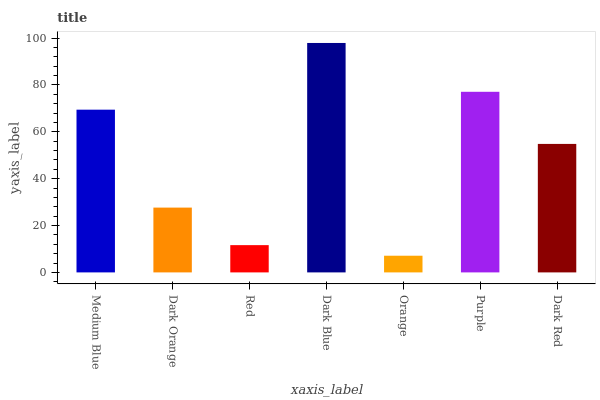Is Orange the minimum?
Answer yes or no. Yes. Is Dark Blue the maximum?
Answer yes or no. Yes. Is Dark Orange the minimum?
Answer yes or no. No. Is Dark Orange the maximum?
Answer yes or no. No. Is Medium Blue greater than Dark Orange?
Answer yes or no. Yes. Is Dark Orange less than Medium Blue?
Answer yes or no. Yes. Is Dark Orange greater than Medium Blue?
Answer yes or no. No. Is Medium Blue less than Dark Orange?
Answer yes or no. No. Is Dark Red the high median?
Answer yes or no. Yes. Is Dark Red the low median?
Answer yes or no. Yes. Is Medium Blue the high median?
Answer yes or no. No. Is Medium Blue the low median?
Answer yes or no. No. 